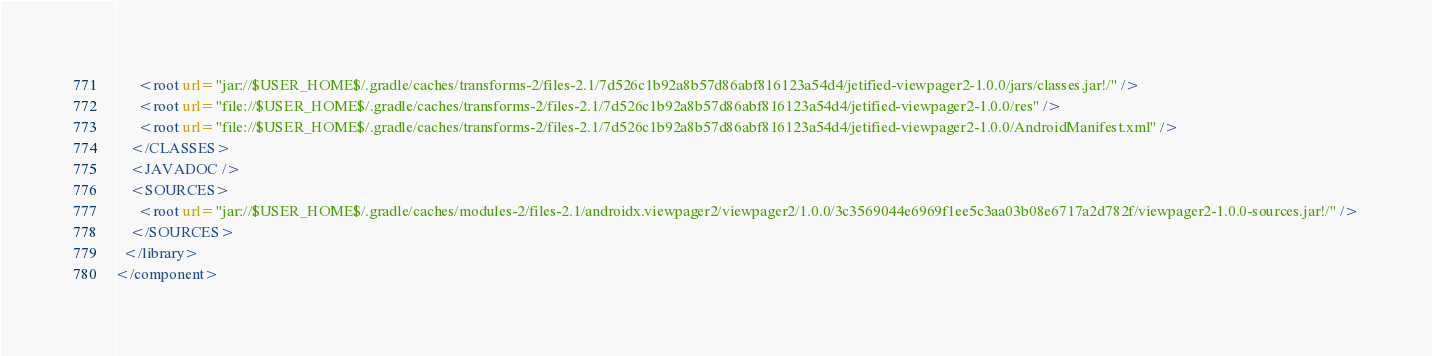Convert code to text. <code><loc_0><loc_0><loc_500><loc_500><_XML_>      <root url="jar://$USER_HOME$/.gradle/caches/transforms-2/files-2.1/7d526c1b92a8b57d86abf816123a54d4/jetified-viewpager2-1.0.0/jars/classes.jar!/" />
      <root url="file://$USER_HOME$/.gradle/caches/transforms-2/files-2.1/7d526c1b92a8b57d86abf816123a54d4/jetified-viewpager2-1.0.0/res" />
      <root url="file://$USER_HOME$/.gradle/caches/transforms-2/files-2.1/7d526c1b92a8b57d86abf816123a54d4/jetified-viewpager2-1.0.0/AndroidManifest.xml" />
    </CLASSES>
    <JAVADOC />
    <SOURCES>
      <root url="jar://$USER_HOME$/.gradle/caches/modules-2/files-2.1/androidx.viewpager2/viewpager2/1.0.0/3c3569044e6969f1ee5c3aa03b08e6717a2d782f/viewpager2-1.0.0-sources.jar!/" />
    </SOURCES>
  </library>
</component></code> 